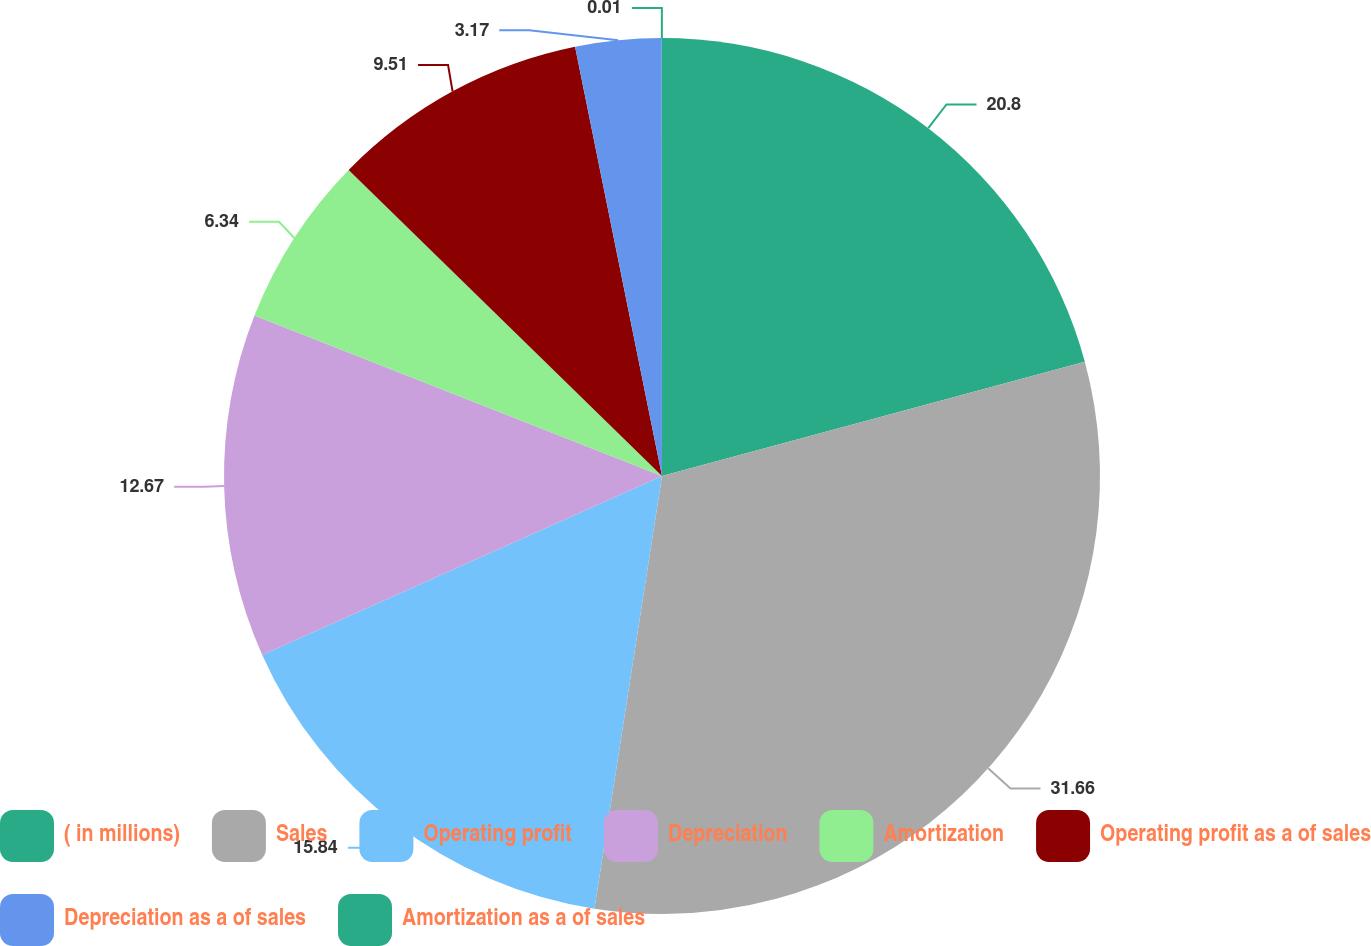Convert chart to OTSL. <chart><loc_0><loc_0><loc_500><loc_500><pie_chart><fcel>( in millions)<fcel>Sales<fcel>Operating profit<fcel>Depreciation<fcel>Amortization<fcel>Operating profit as a of sales<fcel>Depreciation as a of sales<fcel>Amortization as a of sales<nl><fcel>20.8%<fcel>31.67%<fcel>15.84%<fcel>12.67%<fcel>6.34%<fcel>9.51%<fcel>3.17%<fcel>0.01%<nl></chart> 